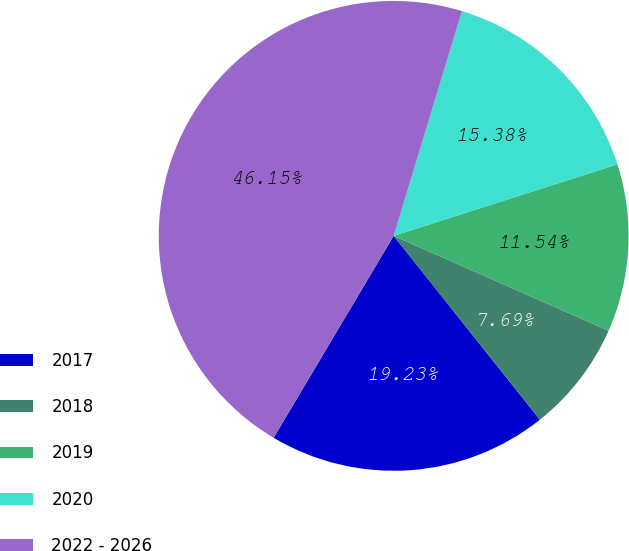Convert chart. <chart><loc_0><loc_0><loc_500><loc_500><pie_chart><fcel>2017<fcel>2018<fcel>2019<fcel>2020<fcel>2022 - 2026<nl><fcel>19.23%<fcel>7.69%<fcel>11.54%<fcel>15.38%<fcel>46.15%<nl></chart> 